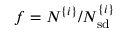<formula> <loc_0><loc_0><loc_500><loc_500>f = N ^ { \{ i \} } / N _ { s d } ^ { \{ i \} }</formula> 